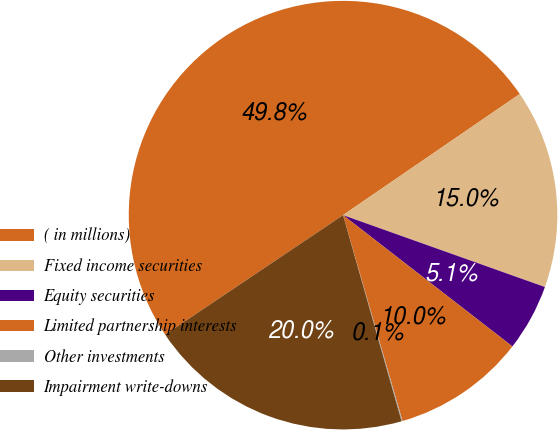<chart> <loc_0><loc_0><loc_500><loc_500><pie_chart><fcel>( in millions)<fcel>Fixed income securities<fcel>Equity securities<fcel>Limited partnership interests<fcel>Other investments<fcel>Impairment write-downs<nl><fcel>49.85%<fcel>15.01%<fcel>5.05%<fcel>10.03%<fcel>0.07%<fcel>19.99%<nl></chart> 